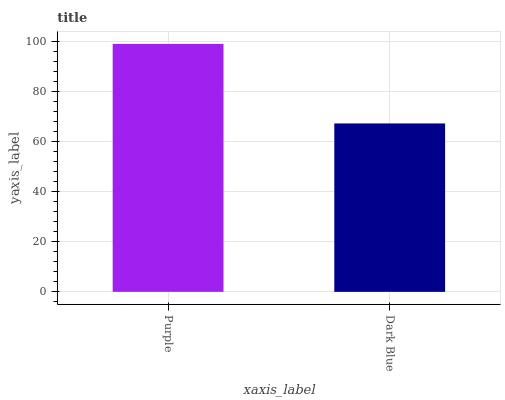Is Dark Blue the minimum?
Answer yes or no. Yes. Is Purple the maximum?
Answer yes or no. Yes. Is Dark Blue the maximum?
Answer yes or no. No. Is Purple greater than Dark Blue?
Answer yes or no. Yes. Is Dark Blue less than Purple?
Answer yes or no. Yes. Is Dark Blue greater than Purple?
Answer yes or no. No. Is Purple less than Dark Blue?
Answer yes or no. No. Is Purple the high median?
Answer yes or no. Yes. Is Dark Blue the low median?
Answer yes or no. Yes. Is Dark Blue the high median?
Answer yes or no. No. Is Purple the low median?
Answer yes or no. No. 